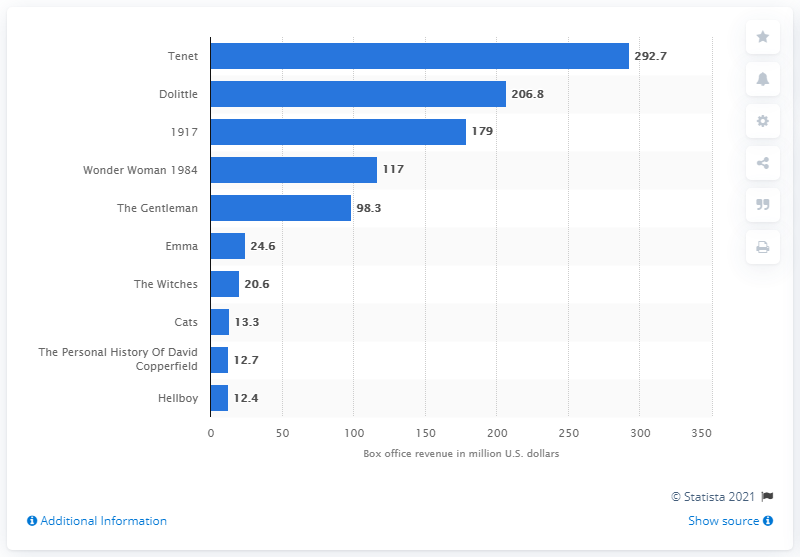Specify some key components in this picture. It has been announced that Tenet, a British independent film, ranked first in the top UK independent films of 2020. Tenet generated $292.7 million in global box office revenue. 